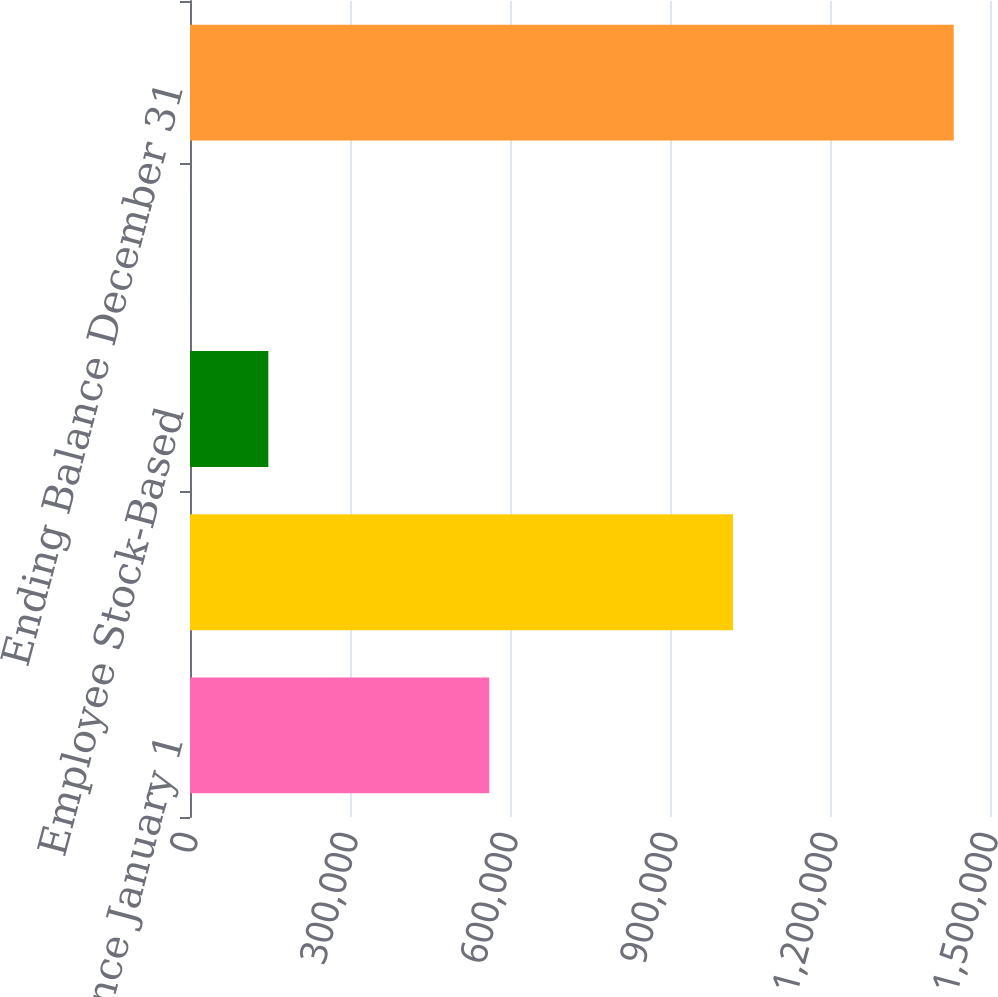Convert chart to OTSL. <chart><loc_0><loc_0><loc_500><loc_500><bar_chart><fcel>Beginning Balance January 1<fcel>Repurchases<fcel>Employee Stock-Based<fcel>Directors' Plan<fcel>Ending Balance December 31<nl><fcel>561152<fcel>1.018e+06<fcel>146877<fcel>252<fcel>1.43202e+06<nl></chart> 